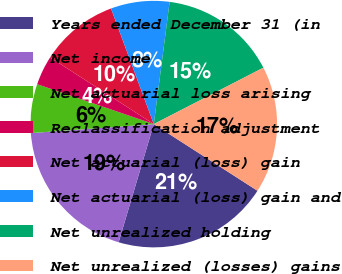Convert chart. <chart><loc_0><loc_0><loc_500><loc_500><pie_chart><fcel>Years ended December 31 (in<fcel>Net income<fcel>Net actuarial loss arising<fcel>Reclassification adjustment<fcel>Net actuarial (loss) gain<fcel>Net actuarial (loss) gain and<fcel>Net unrealized holding<fcel>Net unrealized (losses) gains<nl><fcel>20.51%<fcel>19.23%<fcel>6.41%<fcel>3.85%<fcel>10.26%<fcel>7.69%<fcel>15.38%<fcel>16.66%<nl></chart> 